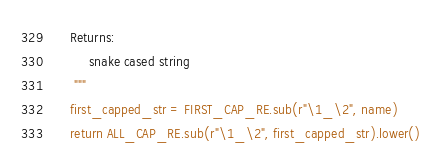<code> <loc_0><loc_0><loc_500><loc_500><_Python_>    Returns:
         snake cased string
     """
    first_capped_str = FIRST_CAP_RE.sub(r"\1_\2", name)
    return ALL_CAP_RE.sub(r"\1_\2", first_capped_str).lower()
</code> 